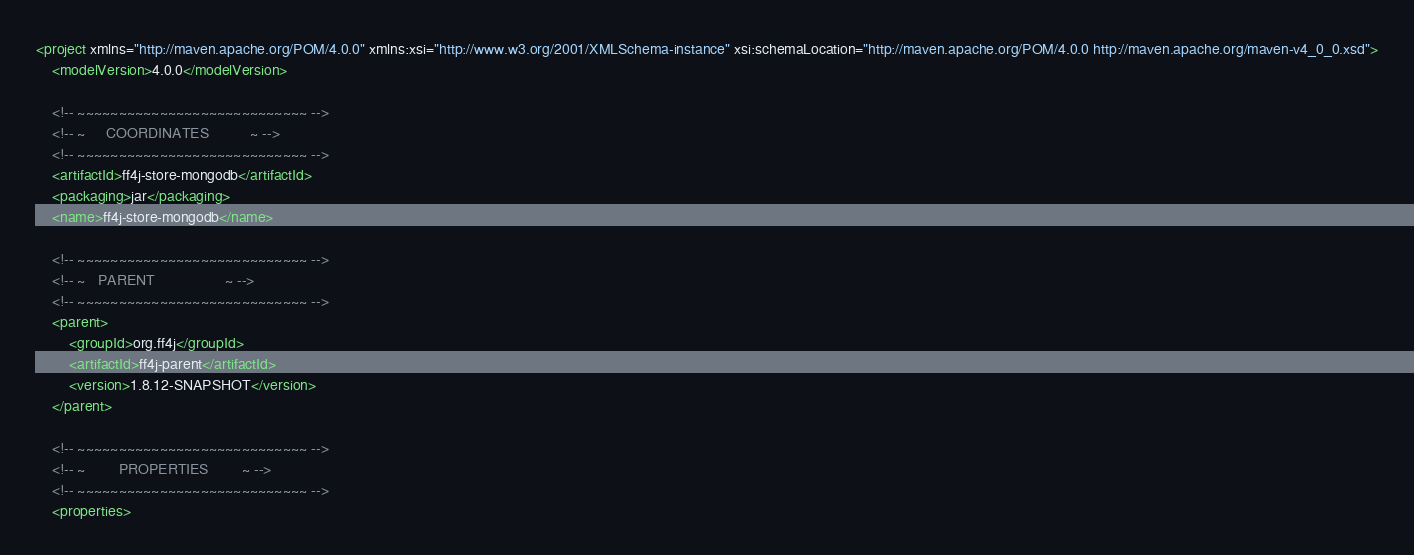Convert code to text. <code><loc_0><loc_0><loc_500><loc_500><_XML_><project xmlns="http://maven.apache.org/POM/4.0.0" xmlns:xsi="http://www.w3.org/2001/XMLSchema-instance" xsi:schemaLocation="http://maven.apache.org/POM/4.0.0 http://maven.apache.org/maven-v4_0_0.xsd">
	<modelVersion>4.0.0</modelVersion>

	<!-- ~~~~~~~~~~~~~~~~~~~~~~~~~~~~ -->
	<!-- ~     COORDINATES          ~ -->
	<!-- ~~~~~~~~~~~~~~~~~~~~~~~~~~~~ -->
	<artifactId>ff4j-store-mongodb</artifactId>
	<packaging>jar</packaging>
	<name>ff4j-store-mongodb</name>
	
	<!-- ~~~~~~~~~~~~~~~~~~~~~~~~~~~~ -->
	<!-- ~   PARENT                 ~ -->
	<!-- ~~~~~~~~~~~~~~~~~~~~~~~~~~~~ -->
	<parent>
		<groupId>org.ff4j</groupId>
		<artifactId>ff4j-parent</artifactId>
		<version>1.8.12-SNAPSHOT</version>
	</parent>

	<!-- ~~~~~~~~~~~~~~~~~~~~~~~~~~~~ -->
	<!-- ~        PROPERTIES        ~ -->
	<!-- ~~~~~~~~~~~~~~~~~~~~~~~~~~~~ -->
	<properties></code> 